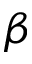Convert formula to latex. <formula><loc_0><loc_0><loc_500><loc_500>\beta</formula> 